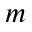<formula> <loc_0><loc_0><loc_500><loc_500>m</formula> 